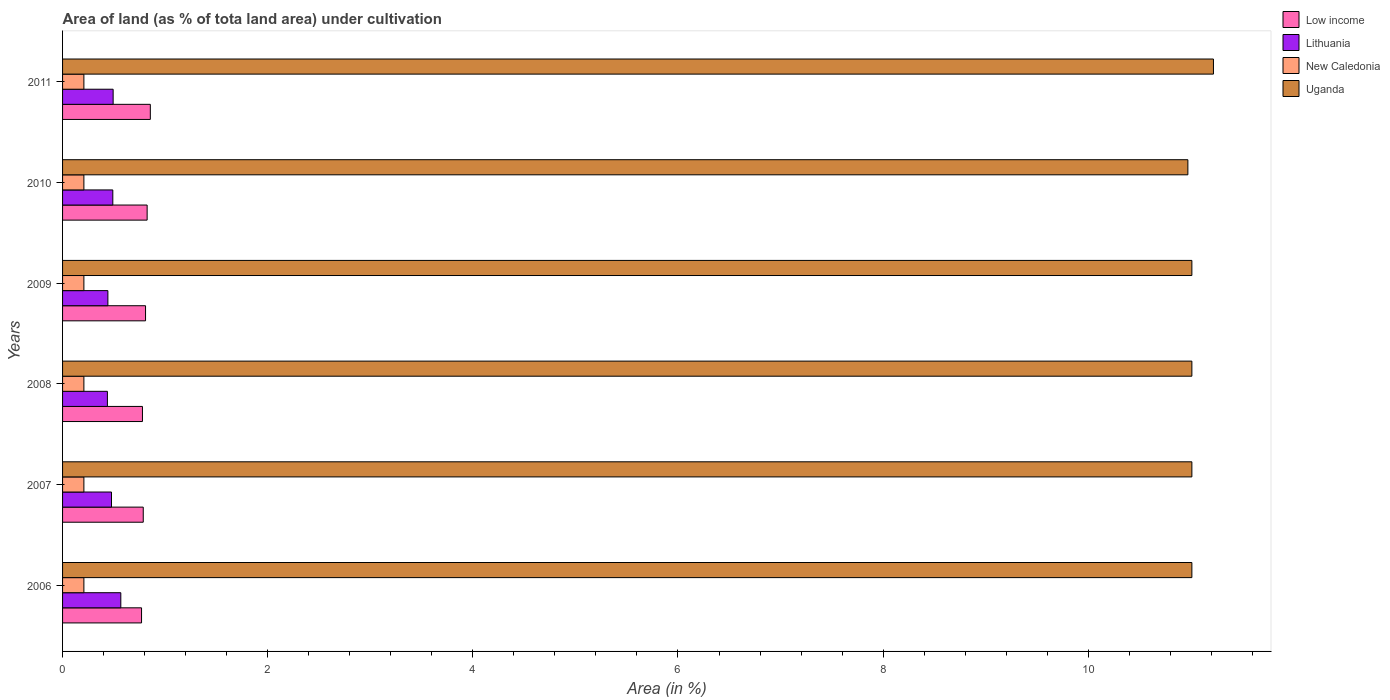How many different coloured bars are there?
Give a very brief answer. 4. How many groups of bars are there?
Your answer should be compact. 6. What is the label of the 3rd group of bars from the top?
Provide a short and direct response. 2009. What is the percentage of land under cultivation in Lithuania in 2011?
Offer a terse response. 0.49. Across all years, what is the maximum percentage of land under cultivation in Lithuania?
Ensure brevity in your answer.  0.57. Across all years, what is the minimum percentage of land under cultivation in Low income?
Offer a very short reply. 0.77. In which year was the percentage of land under cultivation in Low income maximum?
Provide a short and direct response. 2011. What is the total percentage of land under cultivation in Low income in the graph?
Offer a terse response. 4.83. What is the difference between the percentage of land under cultivation in Lithuania in 2008 and that in 2010?
Your answer should be very brief. -0.05. What is the difference between the percentage of land under cultivation in New Caledonia in 2010 and the percentage of land under cultivation in Uganda in 2009?
Keep it short and to the point. -10.8. What is the average percentage of land under cultivation in Lithuania per year?
Give a very brief answer. 0.48. In the year 2010, what is the difference between the percentage of land under cultivation in Lithuania and percentage of land under cultivation in Uganda?
Your response must be concise. -10.48. What is the ratio of the percentage of land under cultivation in Lithuania in 2007 to that in 2010?
Offer a terse response. 0.97. Is the difference between the percentage of land under cultivation in Lithuania in 2010 and 2011 greater than the difference between the percentage of land under cultivation in Uganda in 2010 and 2011?
Provide a short and direct response. Yes. What is the difference between the highest and the second highest percentage of land under cultivation in Lithuania?
Your answer should be very brief. 0.07. What is the difference between the highest and the lowest percentage of land under cultivation in Low income?
Provide a succinct answer. 0.09. Is the sum of the percentage of land under cultivation in New Caledonia in 2007 and 2010 greater than the maximum percentage of land under cultivation in Uganda across all years?
Provide a succinct answer. No. What does the 2nd bar from the top in 2010 represents?
Provide a short and direct response. New Caledonia. What does the 3rd bar from the bottom in 2009 represents?
Provide a short and direct response. New Caledonia. What is the difference between two consecutive major ticks on the X-axis?
Offer a very short reply. 2. Are the values on the major ticks of X-axis written in scientific E-notation?
Ensure brevity in your answer.  No. Does the graph contain any zero values?
Provide a short and direct response. No. How many legend labels are there?
Make the answer very short. 4. How are the legend labels stacked?
Offer a very short reply. Vertical. What is the title of the graph?
Provide a short and direct response. Area of land (as % of tota land area) under cultivation. Does "Upper middle income" appear as one of the legend labels in the graph?
Give a very brief answer. No. What is the label or title of the X-axis?
Provide a succinct answer. Area (in %). What is the label or title of the Y-axis?
Provide a succinct answer. Years. What is the Area (in %) in Low income in 2006?
Ensure brevity in your answer.  0.77. What is the Area (in %) in Lithuania in 2006?
Keep it short and to the point. 0.57. What is the Area (in %) of New Caledonia in 2006?
Ensure brevity in your answer.  0.21. What is the Area (in %) in Uganda in 2006?
Your answer should be very brief. 11.01. What is the Area (in %) of Low income in 2007?
Offer a terse response. 0.79. What is the Area (in %) in Lithuania in 2007?
Keep it short and to the point. 0.48. What is the Area (in %) in New Caledonia in 2007?
Your response must be concise. 0.21. What is the Area (in %) in Uganda in 2007?
Provide a short and direct response. 11.01. What is the Area (in %) in Low income in 2008?
Keep it short and to the point. 0.78. What is the Area (in %) in Lithuania in 2008?
Give a very brief answer. 0.44. What is the Area (in %) in New Caledonia in 2008?
Ensure brevity in your answer.  0.21. What is the Area (in %) of Uganda in 2008?
Your response must be concise. 11.01. What is the Area (in %) in Low income in 2009?
Provide a succinct answer. 0.81. What is the Area (in %) in Lithuania in 2009?
Your answer should be compact. 0.44. What is the Area (in %) of New Caledonia in 2009?
Offer a terse response. 0.21. What is the Area (in %) in Uganda in 2009?
Your answer should be compact. 11.01. What is the Area (in %) in Low income in 2010?
Ensure brevity in your answer.  0.82. What is the Area (in %) of Lithuania in 2010?
Offer a terse response. 0.49. What is the Area (in %) of New Caledonia in 2010?
Your answer should be very brief. 0.21. What is the Area (in %) of Uganda in 2010?
Your answer should be compact. 10.97. What is the Area (in %) of Low income in 2011?
Ensure brevity in your answer.  0.86. What is the Area (in %) in Lithuania in 2011?
Give a very brief answer. 0.49. What is the Area (in %) in New Caledonia in 2011?
Your response must be concise. 0.21. What is the Area (in %) of Uganda in 2011?
Your response must be concise. 11.22. Across all years, what is the maximum Area (in %) of Low income?
Provide a short and direct response. 0.86. Across all years, what is the maximum Area (in %) of Lithuania?
Offer a terse response. 0.57. Across all years, what is the maximum Area (in %) of New Caledonia?
Your response must be concise. 0.21. Across all years, what is the maximum Area (in %) of Uganda?
Offer a terse response. 11.22. Across all years, what is the minimum Area (in %) of Low income?
Keep it short and to the point. 0.77. Across all years, what is the minimum Area (in %) of Lithuania?
Make the answer very short. 0.44. Across all years, what is the minimum Area (in %) of New Caledonia?
Ensure brevity in your answer.  0.21. Across all years, what is the minimum Area (in %) of Uganda?
Offer a very short reply. 10.97. What is the total Area (in %) in Low income in the graph?
Offer a very short reply. 4.83. What is the total Area (in %) of Lithuania in the graph?
Keep it short and to the point. 2.91. What is the total Area (in %) in New Caledonia in the graph?
Make the answer very short. 1.25. What is the total Area (in %) of Uganda in the graph?
Offer a very short reply. 66.23. What is the difference between the Area (in %) in Low income in 2006 and that in 2007?
Give a very brief answer. -0.02. What is the difference between the Area (in %) in Lithuania in 2006 and that in 2007?
Keep it short and to the point. 0.09. What is the difference between the Area (in %) in Low income in 2006 and that in 2008?
Offer a very short reply. -0.01. What is the difference between the Area (in %) of Lithuania in 2006 and that in 2008?
Your answer should be very brief. 0.13. What is the difference between the Area (in %) of Low income in 2006 and that in 2009?
Offer a very short reply. -0.04. What is the difference between the Area (in %) in Lithuania in 2006 and that in 2009?
Provide a short and direct response. 0.13. What is the difference between the Area (in %) of Low income in 2006 and that in 2010?
Provide a short and direct response. -0.05. What is the difference between the Area (in %) of Lithuania in 2006 and that in 2010?
Your response must be concise. 0.08. What is the difference between the Area (in %) in New Caledonia in 2006 and that in 2010?
Your answer should be compact. 0. What is the difference between the Area (in %) in Uganda in 2006 and that in 2010?
Ensure brevity in your answer.  0.04. What is the difference between the Area (in %) of Low income in 2006 and that in 2011?
Give a very brief answer. -0.09. What is the difference between the Area (in %) in Lithuania in 2006 and that in 2011?
Offer a very short reply. 0.07. What is the difference between the Area (in %) of New Caledonia in 2006 and that in 2011?
Provide a short and direct response. 0. What is the difference between the Area (in %) of Uganda in 2006 and that in 2011?
Make the answer very short. -0.21. What is the difference between the Area (in %) of Low income in 2007 and that in 2008?
Give a very brief answer. 0.01. What is the difference between the Area (in %) in Lithuania in 2007 and that in 2008?
Your answer should be very brief. 0.04. What is the difference between the Area (in %) of New Caledonia in 2007 and that in 2008?
Offer a very short reply. 0. What is the difference between the Area (in %) in Low income in 2007 and that in 2009?
Provide a short and direct response. -0.02. What is the difference between the Area (in %) of Lithuania in 2007 and that in 2009?
Ensure brevity in your answer.  0.04. What is the difference between the Area (in %) in New Caledonia in 2007 and that in 2009?
Your answer should be very brief. 0. What is the difference between the Area (in %) in Low income in 2007 and that in 2010?
Your answer should be very brief. -0.04. What is the difference between the Area (in %) of Lithuania in 2007 and that in 2010?
Make the answer very short. -0.01. What is the difference between the Area (in %) in Uganda in 2007 and that in 2010?
Make the answer very short. 0.04. What is the difference between the Area (in %) in Low income in 2007 and that in 2011?
Your response must be concise. -0.07. What is the difference between the Area (in %) of Lithuania in 2007 and that in 2011?
Give a very brief answer. -0.02. What is the difference between the Area (in %) of New Caledonia in 2007 and that in 2011?
Provide a short and direct response. 0. What is the difference between the Area (in %) of Uganda in 2007 and that in 2011?
Keep it short and to the point. -0.21. What is the difference between the Area (in %) of Low income in 2008 and that in 2009?
Provide a short and direct response. -0.03. What is the difference between the Area (in %) in Lithuania in 2008 and that in 2009?
Ensure brevity in your answer.  -0. What is the difference between the Area (in %) in New Caledonia in 2008 and that in 2009?
Offer a terse response. 0. What is the difference between the Area (in %) of Low income in 2008 and that in 2010?
Your answer should be compact. -0.05. What is the difference between the Area (in %) in Lithuania in 2008 and that in 2010?
Provide a short and direct response. -0.05. What is the difference between the Area (in %) in Uganda in 2008 and that in 2010?
Offer a very short reply. 0.04. What is the difference between the Area (in %) in Low income in 2008 and that in 2011?
Ensure brevity in your answer.  -0.08. What is the difference between the Area (in %) of Lithuania in 2008 and that in 2011?
Ensure brevity in your answer.  -0.06. What is the difference between the Area (in %) of New Caledonia in 2008 and that in 2011?
Offer a very short reply. 0. What is the difference between the Area (in %) of Uganda in 2008 and that in 2011?
Offer a very short reply. -0.21. What is the difference between the Area (in %) of Low income in 2009 and that in 2010?
Provide a succinct answer. -0.02. What is the difference between the Area (in %) in Lithuania in 2009 and that in 2010?
Offer a terse response. -0.05. What is the difference between the Area (in %) in New Caledonia in 2009 and that in 2010?
Your answer should be compact. 0. What is the difference between the Area (in %) of Uganda in 2009 and that in 2010?
Give a very brief answer. 0.04. What is the difference between the Area (in %) of Low income in 2009 and that in 2011?
Provide a short and direct response. -0.05. What is the difference between the Area (in %) of Lithuania in 2009 and that in 2011?
Provide a succinct answer. -0.05. What is the difference between the Area (in %) of Uganda in 2009 and that in 2011?
Give a very brief answer. -0.21. What is the difference between the Area (in %) in Low income in 2010 and that in 2011?
Provide a succinct answer. -0.03. What is the difference between the Area (in %) of Lithuania in 2010 and that in 2011?
Offer a terse response. -0. What is the difference between the Area (in %) in Uganda in 2010 and that in 2011?
Ensure brevity in your answer.  -0.25. What is the difference between the Area (in %) in Low income in 2006 and the Area (in %) in Lithuania in 2007?
Keep it short and to the point. 0.29. What is the difference between the Area (in %) of Low income in 2006 and the Area (in %) of New Caledonia in 2007?
Give a very brief answer. 0.56. What is the difference between the Area (in %) in Low income in 2006 and the Area (in %) in Uganda in 2007?
Your answer should be very brief. -10.24. What is the difference between the Area (in %) of Lithuania in 2006 and the Area (in %) of New Caledonia in 2007?
Your answer should be compact. 0.36. What is the difference between the Area (in %) of Lithuania in 2006 and the Area (in %) of Uganda in 2007?
Give a very brief answer. -10.44. What is the difference between the Area (in %) in New Caledonia in 2006 and the Area (in %) in Uganda in 2007?
Give a very brief answer. -10.8. What is the difference between the Area (in %) in Low income in 2006 and the Area (in %) in Lithuania in 2008?
Offer a terse response. 0.33. What is the difference between the Area (in %) of Low income in 2006 and the Area (in %) of New Caledonia in 2008?
Provide a short and direct response. 0.56. What is the difference between the Area (in %) of Low income in 2006 and the Area (in %) of Uganda in 2008?
Your response must be concise. -10.24. What is the difference between the Area (in %) of Lithuania in 2006 and the Area (in %) of New Caledonia in 2008?
Provide a succinct answer. 0.36. What is the difference between the Area (in %) of Lithuania in 2006 and the Area (in %) of Uganda in 2008?
Your answer should be very brief. -10.44. What is the difference between the Area (in %) in New Caledonia in 2006 and the Area (in %) in Uganda in 2008?
Your response must be concise. -10.8. What is the difference between the Area (in %) of Low income in 2006 and the Area (in %) of Lithuania in 2009?
Keep it short and to the point. 0.33. What is the difference between the Area (in %) of Low income in 2006 and the Area (in %) of New Caledonia in 2009?
Your answer should be very brief. 0.56. What is the difference between the Area (in %) in Low income in 2006 and the Area (in %) in Uganda in 2009?
Provide a succinct answer. -10.24. What is the difference between the Area (in %) in Lithuania in 2006 and the Area (in %) in New Caledonia in 2009?
Your response must be concise. 0.36. What is the difference between the Area (in %) in Lithuania in 2006 and the Area (in %) in Uganda in 2009?
Your response must be concise. -10.44. What is the difference between the Area (in %) in New Caledonia in 2006 and the Area (in %) in Uganda in 2009?
Your answer should be very brief. -10.8. What is the difference between the Area (in %) in Low income in 2006 and the Area (in %) in Lithuania in 2010?
Make the answer very short. 0.28. What is the difference between the Area (in %) in Low income in 2006 and the Area (in %) in New Caledonia in 2010?
Ensure brevity in your answer.  0.56. What is the difference between the Area (in %) of Low income in 2006 and the Area (in %) of Uganda in 2010?
Ensure brevity in your answer.  -10.2. What is the difference between the Area (in %) in Lithuania in 2006 and the Area (in %) in New Caledonia in 2010?
Offer a very short reply. 0.36. What is the difference between the Area (in %) in Lithuania in 2006 and the Area (in %) in Uganda in 2010?
Offer a terse response. -10.4. What is the difference between the Area (in %) in New Caledonia in 2006 and the Area (in %) in Uganda in 2010?
Keep it short and to the point. -10.76. What is the difference between the Area (in %) in Low income in 2006 and the Area (in %) in Lithuania in 2011?
Offer a terse response. 0.28. What is the difference between the Area (in %) of Low income in 2006 and the Area (in %) of New Caledonia in 2011?
Make the answer very short. 0.56. What is the difference between the Area (in %) of Low income in 2006 and the Area (in %) of Uganda in 2011?
Your answer should be very brief. -10.45. What is the difference between the Area (in %) in Lithuania in 2006 and the Area (in %) in New Caledonia in 2011?
Keep it short and to the point. 0.36. What is the difference between the Area (in %) of Lithuania in 2006 and the Area (in %) of Uganda in 2011?
Your response must be concise. -10.65. What is the difference between the Area (in %) of New Caledonia in 2006 and the Area (in %) of Uganda in 2011?
Your response must be concise. -11.01. What is the difference between the Area (in %) of Low income in 2007 and the Area (in %) of Lithuania in 2008?
Your answer should be compact. 0.35. What is the difference between the Area (in %) of Low income in 2007 and the Area (in %) of New Caledonia in 2008?
Your answer should be very brief. 0.58. What is the difference between the Area (in %) in Low income in 2007 and the Area (in %) in Uganda in 2008?
Give a very brief answer. -10.22. What is the difference between the Area (in %) of Lithuania in 2007 and the Area (in %) of New Caledonia in 2008?
Your answer should be compact. 0.27. What is the difference between the Area (in %) of Lithuania in 2007 and the Area (in %) of Uganda in 2008?
Offer a terse response. -10.53. What is the difference between the Area (in %) of New Caledonia in 2007 and the Area (in %) of Uganda in 2008?
Your response must be concise. -10.8. What is the difference between the Area (in %) of Low income in 2007 and the Area (in %) of Lithuania in 2009?
Offer a very short reply. 0.34. What is the difference between the Area (in %) of Low income in 2007 and the Area (in %) of New Caledonia in 2009?
Offer a terse response. 0.58. What is the difference between the Area (in %) of Low income in 2007 and the Area (in %) of Uganda in 2009?
Make the answer very short. -10.22. What is the difference between the Area (in %) in Lithuania in 2007 and the Area (in %) in New Caledonia in 2009?
Your answer should be very brief. 0.27. What is the difference between the Area (in %) in Lithuania in 2007 and the Area (in %) in Uganda in 2009?
Provide a succinct answer. -10.53. What is the difference between the Area (in %) in New Caledonia in 2007 and the Area (in %) in Uganda in 2009?
Ensure brevity in your answer.  -10.8. What is the difference between the Area (in %) in Low income in 2007 and the Area (in %) in Lithuania in 2010?
Your answer should be compact. 0.3. What is the difference between the Area (in %) in Low income in 2007 and the Area (in %) in New Caledonia in 2010?
Ensure brevity in your answer.  0.58. What is the difference between the Area (in %) of Low income in 2007 and the Area (in %) of Uganda in 2010?
Ensure brevity in your answer.  -10.18. What is the difference between the Area (in %) of Lithuania in 2007 and the Area (in %) of New Caledonia in 2010?
Your answer should be very brief. 0.27. What is the difference between the Area (in %) in Lithuania in 2007 and the Area (in %) in Uganda in 2010?
Ensure brevity in your answer.  -10.49. What is the difference between the Area (in %) of New Caledonia in 2007 and the Area (in %) of Uganda in 2010?
Offer a terse response. -10.76. What is the difference between the Area (in %) in Low income in 2007 and the Area (in %) in Lithuania in 2011?
Ensure brevity in your answer.  0.29. What is the difference between the Area (in %) of Low income in 2007 and the Area (in %) of New Caledonia in 2011?
Keep it short and to the point. 0.58. What is the difference between the Area (in %) in Low income in 2007 and the Area (in %) in Uganda in 2011?
Offer a terse response. -10.43. What is the difference between the Area (in %) in Lithuania in 2007 and the Area (in %) in New Caledonia in 2011?
Ensure brevity in your answer.  0.27. What is the difference between the Area (in %) of Lithuania in 2007 and the Area (in %) of Uganda in 2011?
Provide a succinct answer. -10.74. What is the difference between the Area (in %) of New Caledonia in 2007 and the Area (in %) of Uganda in 2011?
Provide a short and direct response. -11.01. What is the difference between the Area (in %) of Low income in 2008 and the Area (in %) of Lithuania in 2009?
Ensure brevity in your answer.  0.34. What is the difference between the Area (in %) in Low income in 2008 and the Area (in %) in New Caledonia in 2009?
Make the answer very short. 0.57. What is the difference between the Area (in %) in Low income in 2008 and the Area (in %) in Uganda in 2009?
Keep it short and to the point. -10.23. What is the difference between the Area (in %) of Lithuania in 2008 and the Area (in %) of New Caledonia in 2009?
Keep it short and to the point. 0.23. What is the difference between the Area (in %) in Lithuania in 2008 and the Area (in %) in Uganda in 2009?
Your answer should be compact. -10.57. What is the difference between the Area (in %) in New Caledonia in 2008 and the Area (in %) in Uganda in 2009?
Your response must be concise. -10.8. What is the difference between the Area (in %) of Low income in 2008 and the Area (in %) of Lithuania in 2010?
Offer a very short reply. 0.29. What is the difference between the Area (in %) in Low income in 2008 and the Area (in %) in New Caledonia in 2010?
Your response must be concise. 0.57. What is the difference between the Area (in %) of Low income in 2008 and the Area (in %) of Uganda in 2010?
Offer a terse response. -10.19. What is the difference between the Area (in %) of Lithuania in 2008 and the Area (in %) of New Caledonia in 2010?
Your answer should be compact. 0.23. What is the difference between the Area (in %) of Lithuania in 2008 and the Area (in %) of Uganda in 2010?
Give a very brief answer. -10.53. What is the difference between the Area (in %) of New Caledonia in 2008 and the Area (in %) of Uganda in 2010?
Provide a succinct answer. -10.76. What is the difference between the Area (in %) of Low income in 2008 and the Area (in %) of Lithuania in 2011?
Your response must be concise. 0.29. What is the difference between the Area (in %) in Low income in 2008 and the Area (in %) in New Caledonia in 2011?
Your answer should be very brief. 0.57. What is the difference between the Area (in %) in Low income in 2008 and the Area (in %) in Uganda in 2011?
Make the answer very short. -10.44. What is the difference between the Area (in %) in Lithuania in 2008 and the Area (in %) in New Caledonia in 2011?
Give a very brief answer. 0.23. What is the difference between the Area (in %) of Lithuania in 2008 and the Area (in %) of Uganda in 2011?
Your answer should be compact. -10.78. What is the difference between the Area (in %) in New Caledonia in 2008 and the Area (in %) in Uganda in 2011?
Provide a short and direct response. -11.01. What is the difference between the Area (in %) in Low income in 2009 and the Area (in %) in Lithuania in 2010?
Offer a terse response. 0.32. What is the difference between the Area (in %) of Low income in 2009 and the Area (in %) of New Caledonia in 2010?
Your answer should be very brief. 0.6. What is the difference between the Area (in %) of Low income in 2009 and the Area (in %) of Uganda in 2010?
Provide a succinct answer. -10.16. What is the difference between the Area (in %) in Lithuania in 2009 and the Area (in %) in New Caledonia in 2010?
Ensure brevity in your answer.  0.23. What is the difference between the Area (in %) in Lithuania in 2009 and the Area (in %) in Uganda in 2010?
Ensure brevity in your answer.  -10.53. What is the difference between the Area (in %) of New Caledonia in 2009 and the Area (in %) of Uganda in 2010?
Offer a very short reply. -10.76. What is the difference between the Area (in %) in Low income in 2009 and the Area (in %) in Lithuania in 2011?
Keep it short and to the point. 0.32. What is the difference between the Area (in %) of Low income in 2009 and the Area (in %) of New Caledonia in 2011?
Give a very brief answer. 0.6. What is the difference between the Area (in %) in Low income in 2009 and the Area (in %) in Uganda in 2011?
Offer a very short reply. -10.41. What is the difference between the Area (in %) of Lithuania in 2009 and the Area (in %) of New Caledonia in 2011?
Your answer should be very brief. 0.23. What is the difference between the Area (in %) in Lithuania in 2009 and the Area (in %) in Uganda in 2011?
Your answer should be very brief. -10.78. What is the difference between the Area (in %) of New Caledonia in 2009 and the Area (in %) of Uganda in 2011?
Give a very brief answer. -11.01. What is the difference between the Area (in %) of Low income in 2010 and the Area (in %) of Lithuania in 2011?
Your response must be concise. 0.33. What is the difference between the Area (in %) in Low income in 2010 and the Area (in %) in New Caledonia in 2011?
Offer a terse response. 0.62. What is the difference between the Area (in %) in Low income in 2010 and the Area (in %) in Uganda in 2011?
Offer a terse response. -10.4. What is the difference between the Area (in %) in Lithuania in 2010 and the Area (in %) in New Caledonia in 2011?
Keep it short and to the point. 0.28. What is the difference between the Area (in %) of Lithuania in 2010 and the Area (in %) of Uganda in 2011?
Give a very brief answer. -10.73. What is the difference between the Area (in %) of New Caledonia in 2010 and the Area (in %) of Uganda in 2011?
Provide a succinct answer. -11.01. What is the average Area (in %) of Low income per year?
Ensure brevity in your answer.  0.8. What is the average Area (in %) in Lithuania per year?
Provide a succinct answer. 0.48. What is the average Area (in %) of New Caledonia per year?
Make the answer very short. 0.21. What is the average Area (in %) of Uganda per year?
Keep it short and to the point. 11.04. In the year 2006, what is the difference between the Area (in %) of Low income and Area (in %) of Lithuania?
Your answer should be very brief. 0.2. In the year 2006, what is the difference between the Area (in %) of Low income and Area (in %) of New Caledonia?
Your answer should be very brief. 0.56. In the year 2006, what is the difference between the Area (in %) in Low income and Area (in %) in Uganda?
Make the answer very short. -10.24. In the year 2006, what is the difference between the Area (in %) in Lithuania and Area (in %) in New Caledonia?
Your response must be concise. 0.36. In the year 2006, what is the difference between the Area (in %) in Lithuania and Area (in %) in Uganda?
Provide a short and direct response. -10.44. In the year 2006, what is the difference between the Area (in %) of New Caledonia and Area (in %) of Uganda?
Offer a terse response. -10.8. In the year 2007, what is the difference between the Area (in %) of Low income and Area (in %) of Lithuania?
Provide a succinct answer. 0.31. In the year 2007, what is the difference between the Area (in %) in Low income and Area (in %) in New Caledonia?
Your response must be concise. 0.58. In the year 2007, what is the difference between the Area (in %) of Low income and Area (in %) of Uganda?
Offer a very short reply. -10.22. In the year 2007, what is the difference between the Area (in %) of Lithuania and Area (in %) of New Caledonia?
Ensure brevity in your answer.  0.27. In the year 2007, what is the difference between the Area (in %) in Lithuania and Area (in %) in Uganda?
Make the answer very short. -10.53. In the year 2007, what is the difference between the Area (in %) in New Caledonia and Area (in %) in Uganda?
Provide a short and direct response. -10.8. In the year 2008, what is the difference between the Area (in %) in Low income and Area (in %) in Lithuania?
Your answer should be compact. 0.34. In the year 2008, what is the difference between the Area (in %) in Low income and Area (in %) in New Caledonia?
Your answer should be compact. 0.57. In the year 2008, what is the difference between the Area (in %) of Low income and Area (in %) of Uganda?
Keep it short and to the point. -10.23. In the year 2008, what is the difference between the Area (in %) in Lithuania and Area (in %) in New Caledonia?
Make the answer very short. 0.23. In the year 2008, what is the difference between the Area (in %) in Lithuania and Area (in %) in Uganda?
Provide a succinct answer. -10.57. In the year 2008, what is the difference between the Area (in %) of New Caledonia and Area (in %) of Uganda?
Your answer should be very brief. -10.8. In the year 2009, what is the difference between the Area (in %) in Low income and Area (in %) in Lithuania?
Your response must be concise. 0.37. In the year 2009, what is the difference between the Area (in %) of Low income and Area (in %) of New Caledonia?
Make the answer very short. 0.6. In the year 2009, what is the difference between the Area (in %) in Low income and Area (in %) in Uganda?
Your answer should be very brief. -10.2. In the year 2009, what is the difference between the Area (in %) of Lithuania and Area (in %) of New Caledonia?
Give a very brief answer. 0.23. In the year 2009, what is the difference between the Area (in %) in Lithuania and Area (in %) in Uganda?
Make the answer very short. -10.57. In the year 2009, what is the difference between the Area (in %) of New Caledonia and Area (in %) of Uganda?
Keep it short and to the point. -10.8. In the year 2010, what is the difference between the Area (in %) in Low income and Area (in %) in Lithuania?
Offer a terse response. 0.33. In the year 2010, what is the difference between the Area (in %) of Low income and Area (in %) of New Caledonia?
Ensure brevity in your answer.  0.62. In the year 2010, what is the difference between the Area (in %) of Low income and Area (in %) of Uganda?
Provide a short and direct response. -10.15. In the year 2010, what is the difference between the Area (in %) in Lithuania and Area (in %) in New Caledonia?
Offer a very short reply. 0.28. In the year 2010, what is the difference between the Area (in %) of Lithuania and Area (in %) of Uganda?
Give a very brief answer. -10.48. In the year 2010, what is the difference between the Area (in %) of New Caledonia and Area (in %) of Uganda?
Offer a very short reply. -10.76. In the year 2011, what is the difference between the Area (in %) in Low income and Area (in %) in Lithuania?
Provide a succinct answer. 0.36. In the year 2011, what is the difference between the Area (in %) of Low income and Area (in %) of New Caledonia?
Offer a terse response. 0.65. In the year 2011, what is the difference between the Area (in %) in Low income and Area (in %) in Uganda?
Offer a very short reply. -10.37. In the year 2011, what is the difference between the Area (in %) in Lithuania and Area (in %) in New Caledonia?
Your response must be concise. 0.29. In the year 2011, what is the difference between the Area (in %) of Lithuania and Area (in %) of Uganda?
Provide a succinct answer. -10.73. In the year 2011, what is the difference between the Area (in %) of New Caledonia and Area (in %) of Uganda?
Keep it short and to the point. -11.01. What is the ratio of the Area (in %) in Low income in 2006 to that in 2007?
Ensure brevity in your answer.  0.98. What is the ratio of the Area (in %) in Lithuania in 2006 to that in 2007?
Your answer should be compact. 1.19. What is the ratio of the Area (in %) in Lithuania in 2006 to that in 2008?
Make the answer very short. 1.3. What is the ratio of the Area (in %) in New Caledonia in 2006 to that in 2008?
Your answer should be compact. 1. What is the ratio of the Area (in %) in Uganda in 2006 to that in 2008?
Offer a terse response. 1. What is the ratio of the Area (in %) in Low income in 2006 to that in 2009?
Ensure brevity in your answer.  0.95. What is the ratio of the Area (in %) of Lithuania in 2006 to that in 2009?
Ensure brevity in your answer.  1.29. What is the ratio of the Area (in %) of Uganda in 2006 to that in 2009?
Give a very brief answer. 1. What is the ratio of the Area (in %) in Low income in 2006 to that in 2010?
Offer a terse response. 0.93. What is the ratio of the Area (in %) in Lithuania in 2006 to that in 2010?
Give a very brief answer. 1.16. What is the ratio of the Area (in %) in New Caledonia in 2006 to that in 2010?
Offer a terse response. 1. What is the ratio of the Area (in %) of Low income in 2006 to that in 2011?
Offer a terse response. 0.9. What is the ratio of the Area (in %) in Lithuania in 2006 to that in 2011?
Make the answer very short. 1.15. What is the ratio of the Area (in %) of Uganda in 2006 to that in 2011?
Make the answer very short. 0.98. What is the ratio of the Area (in %) of Low income in 2007 to that in 2008?
Keep it short and to the point. 1.01. What is the ratio of the Area (in %) of Lithuania in 2007 to that in 2008?
Give a very brief answer. 1.09. What is the ratio of the Area (in %) in New Caledonia in 2007 to that in 2008?
Your answer should be compact. 1. What is the ratio of the Area (in %) of Low income in 2007 to that in 2009?
Ensure brevity in your answer.  0.97. What is the ratio of the Area (in %) in Lithuania in 2007 to that in 2009?
Make the answer very short. 1.08. What is the ratio of the Area (in %) of Uganda in 2007 to that in 2009?
Provide a short and direct response. 1. What is the ratio of the Area (in %) of Low income in 2007 to that in 2010?
Make the answer very short. 0.95. What is the ratio of the Area (in %) in Lithuania in 2007 to that in 2010?
Ensure brevity in your answer.  0.97. What is the ratio of the Area (in %) in Low income in 2007 to that in 2011?
Keep it short and to the point. 0.92. What is the ratio of the Area (in %) in Lithuania in 2007 to that in 2011?
Provide a short and direct response. 0.97. What is the ratio of the Area (in %) of Uganda in 2007 to that in 2011?
Make the answer very short. 0.98. What is the ratio of the Area (in %) in Low income in 2008 to that in 2009?
Offer a very short reply. 0.96. What is the ratio of the Area (in %) in New Caledonia in 2008 to that in 2009?
Your answer should be compact. 1. What is the ratio of the Area (in %) of Uganda in 2008 to that in 2009?
Provide a short and direct response. 1. What is the ratio of the Area (in %) of Low income in 2008 to that in 2010?
Keep it short and to the point. 0.94. What is the ratio of the Area (in %) of Lithuania in 2008 to that in 2010?
Make the answer very short. 0.89. What is the ratio of the Area (in %) in New Caledonia in 2008 to that in 2010?
Provide a succinct answer. 1. What is the ratio of the Area (in %) in Low income in 2008 to that in 2011?
Provide a succinct answer. 0.91. What is the ratio of the Area (in %) in Lithuania in 2008 to that in 2011?
Offer a very short reply. 0.89. What is the ratio of the Area (in %) of New Caledonia in 2008 to that in 2011?
Provide a succinct answer. 1. What is the ratio of the Area (in %) of Uganda in 2008 to that in 2011?
Offer a terse response. 0.98. What is the ratio of the Area (in %) of Low income in 2009 to that in 2010?
Your answer should be compact. 0.98. What is the ratio of the Area (in %) in Lithuania in 2009 to that in 2010?
Give a very brief answer. 0.9. What is the ratio of the Area (in %) of New Caledonia in 2009 to that in 2010?
Offer a very short reply. 1. What is the ratio of the Area (in %) in Uganda in 2009 to that in 2010?
Your response must be concise. 1. What is the ratio of the Area (in %) in Low income in 2009 to that in 2011?
Offer a terse response. 0.95. What is the ratio of the Area (in %) in Lithuania in 2009 to that in 2011?
Provide a short and direct response. 0.9. What is the ratio of the Area (in %) of New Caledonia in 2009 to that in 2011?
Your answer should be very brief. 1. What is the ratio of the Area (in %) of Uganda in 2009 to that in 2011?
Your answer should be very brief. 0.98. What is the ratio of the Area (in %) in Low income in 2010 to that in 2011?
Provide a short and direct response. 0.96. What is the ratio of the Area (in %) in New Caledonia in 2010 to that in 2011?
Make the answer very short. 1. What is the ratio of the Area (in %) of Uganda in 2010 to that in 2011?
Offer a terse response. 0.98. What is the difference between the highest and the second highest Area (in %) in Low income?
Provide a short and direct response. 0.03. What is the difference between the highest and the second highest Area (in %) in Lithuania?
Your answer should be very brief. 0.07. What is the difference between the highest and the second highest Area (in %) of New Caledonia?
Your answer should be very brief. 0. What is the difference between the highest and the second highest Area (in %) of Uganda?
Offer a very short reply. 0.21. What is the difference between the highest and the lowest Area (in %) in Low income?
Offer a very short reply. 0.09. What is the difference between the highest and the lowest Area (in %) of Lithuania?
Keep it short and to the point. 0.13. What is the difference between the highest and the lowest Area (in %) in New Caledonia?
Provide a succinct answer. 0. What is the difference between the highest and the lowest Area (in %) in Uganda?
Provide a succinct answer. 0.25. 